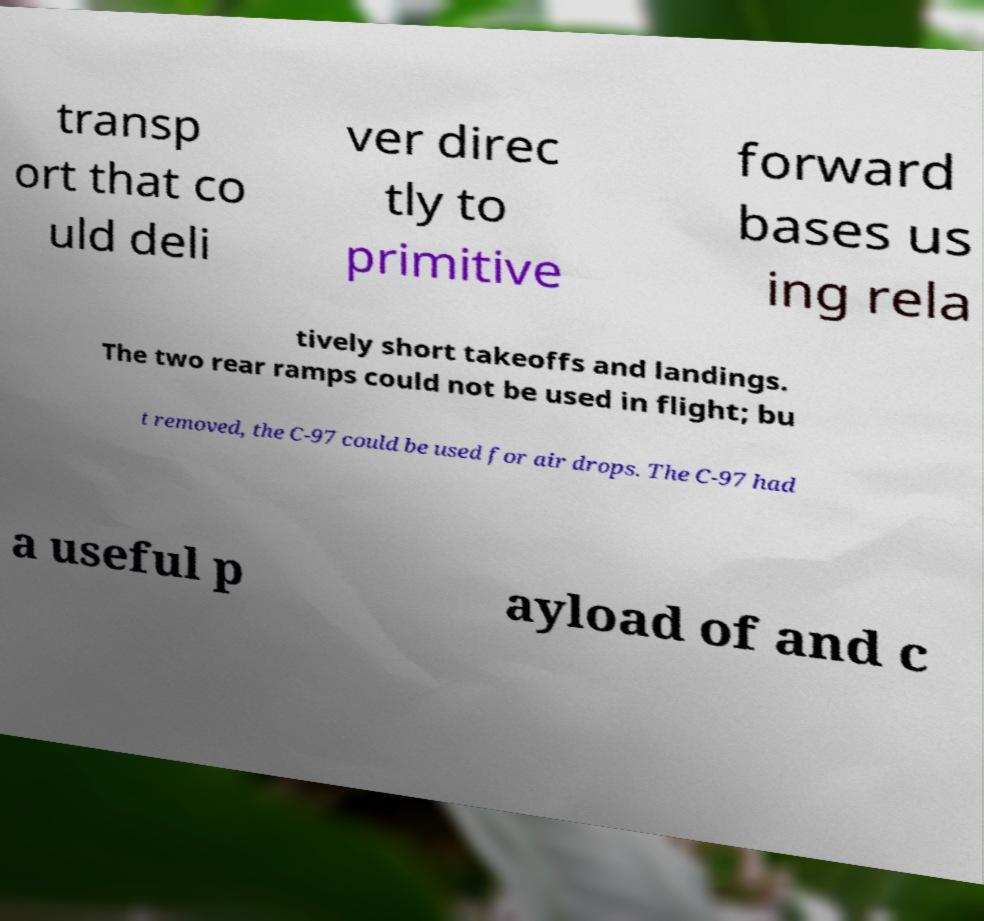Please read and relay the text visible in this image. What does it say? transp ort that co uld deli ver direc tly to primitive forward bases us ing rela tively short takeoffs and landings. The two rear ramps could not be used in flight; bu t removed, the C-97 could be used for air drops. The C-97 had a useful p ayload of and c 